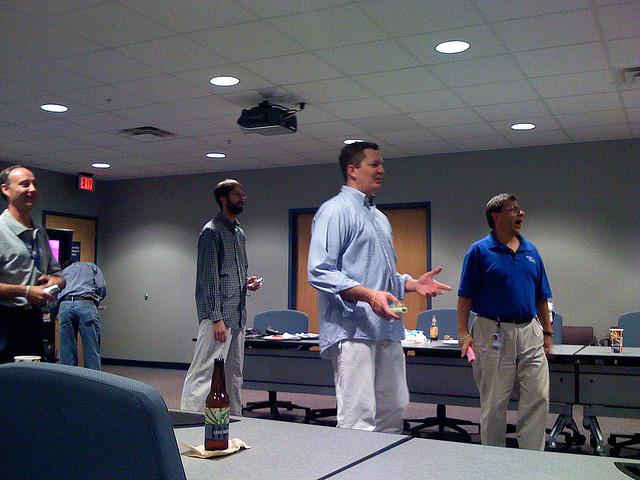What is the purpose of the black object on the ceiling? projecting 